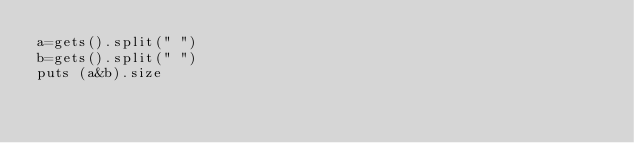Convert code to text. <code><loc_0><loc_0><loc_500><loc_500><_Ruby_>a=gets().split(" ")
b=gets().split(" ")
puts (a&b).size</code> 